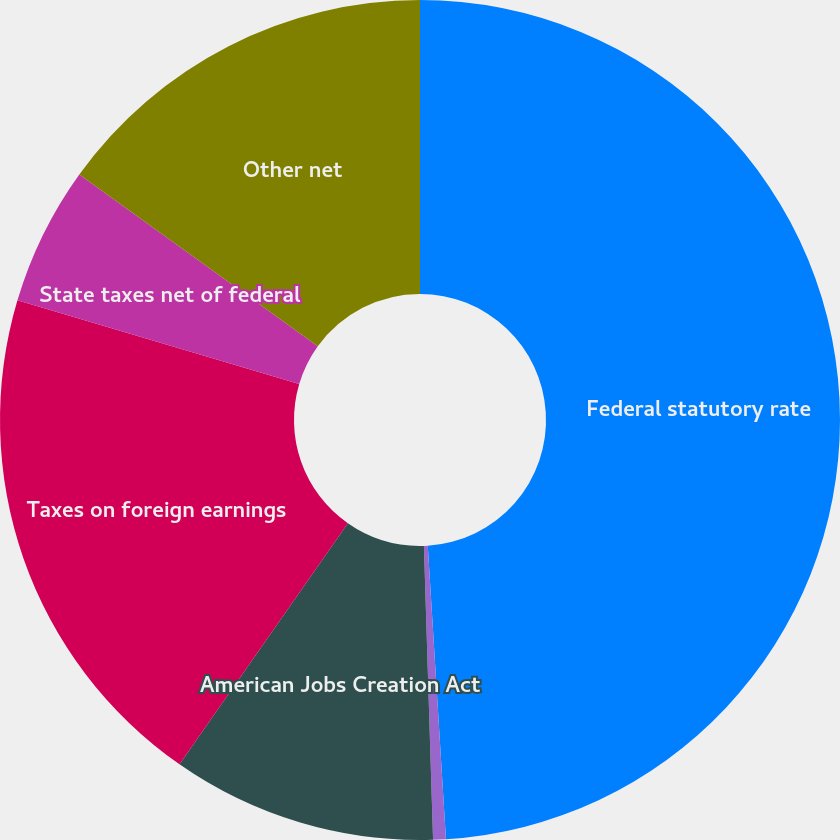Convert chart. <chart><loc_0><loc_0><loc_500><loc_500><pie_chart><fcel>Federal statutory rate<fcel>Export sales benefit<fcel>American Jobs Creation Act<fcel>Taxes on foreign earnings<fcel>State taxes net of federal<fcel>Other net<nl><fcel>49.02%<fcel>0.49%<fcel>10.2%<fcel>19.9%<fcel>5.34%<fcel>15.06%<nl></chart> 